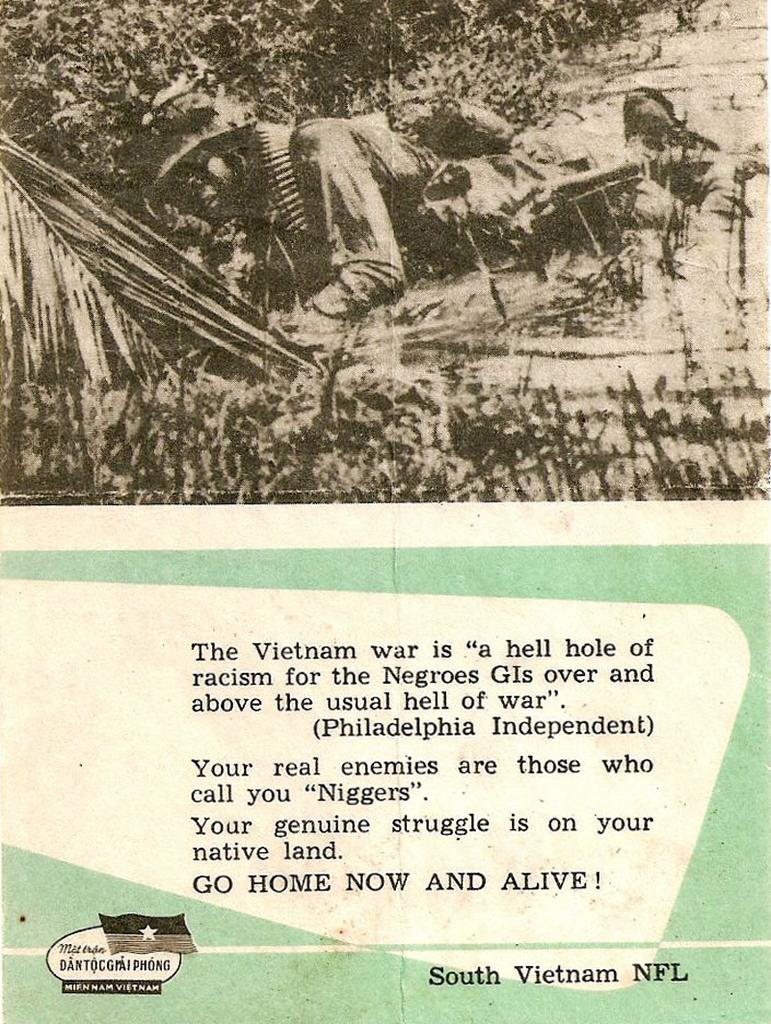What type of visual is depicted in the image? The image is a poster. What is the main subject of the poster? There is a person lying at the top of the poster. What type of natural scenery is present in the poster? There are trees in the poster. Where is the text located on the poster? The text is at the bottom of the poster. What type of record is being discussed by the person in the poster? There is no record or discussion present in the image; it is a poster featuring a person lying at the top and trees in the background. 